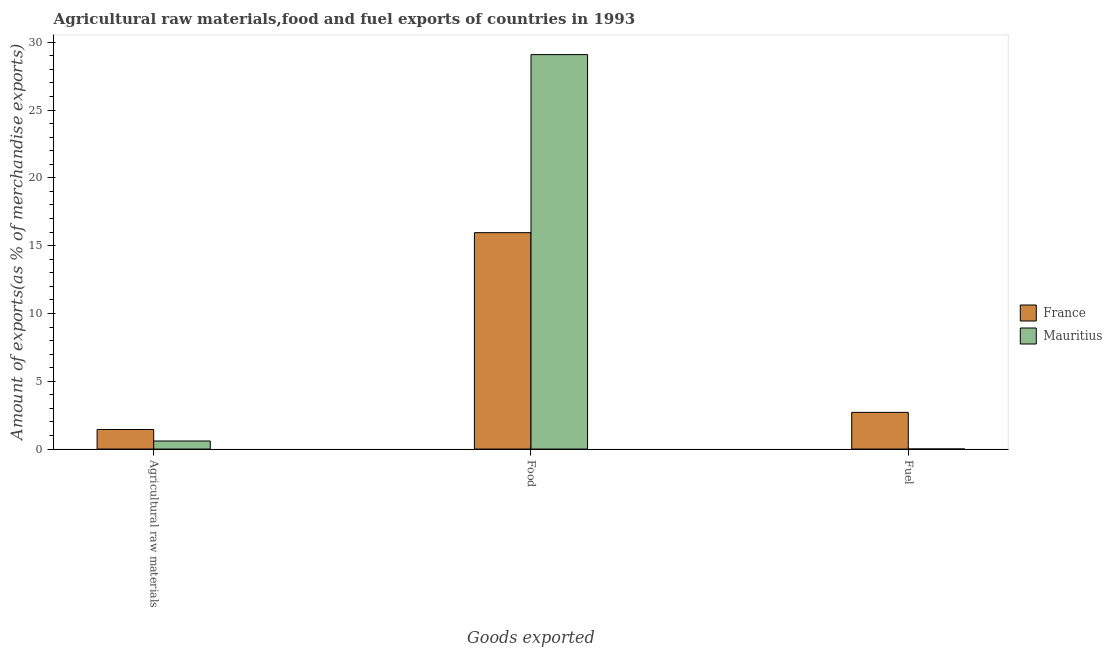How many different coloured bars are there?
Make the answer very short. 2. How many groups of bars are there?
Give a very brief answer. 3. Are the number of bars on each tick of the X-axis equal?
Make the answer very short. Yes. How many bars are there on the 3rd tick from the left?
Keep it short and to the point. 2. How many bars are there on the 3rd tick from the right?
Give a very brief answer. 2. What is the label of the 1st group of bars from the left?
Provide a short and direct response. Agricultural raw materials. What is the percentage of fuel exports in Mauritius?
Offer a very short reply. 0. Across all countries, what is the maximum percentage of food exports?
Offer a very short reply. 29.09. Across all countries, what is the minimum percentage of raw materials exports?
Provide a succinct answer. 0.6. In which country was the percentage of food exports maximum?
Offer a very short reply. Mauritius. What is the total percentage of food exports in the graph?
Provide a short and direct response. 45.04. What is the difference between the percentage of food exports in Mauritius and that in France?
Your response must be concise. 13.13. What is the difference between the percentage of raw materials exports in France and the percentage of food exports in Mauritius?
Your answer should be compact. -27.64. What is the average percentage of food exports per country?
Your answer should be very brief. 22.52. What is the difference between the percentage of raw materials exports and percentage of food exports in Mauritius?
Your answer should be compact. -28.49. In how many countries, is the percentage of food exports greater than 10 %?
Ensure brevity in your answer.  2. What is the ratio of the percentage of fuel exports in Mauritius to that in France?
Ensure brevity in your answer.  0. Is the percentage of fuel exports in Mauritius less than that in France?
Your answer should be very brief. Yes. Is the difference between the percentage of fuel exports in France and Mauritius greater than the difference between the percentage of raw materials exports in France and Mauritius?
Provide a succinct answer. Yes. What is the difference between the highest and the second highest percentage of food exports?
Your answer should be compact. 13.13. What is the difference between the highest and the lowest percentage of food exports?
Keep it short and to the point. 13.13. In how many countries, is the percentage of fuel exports greater than the average percentage of fuel exports taken over all countries?
Ensure brevity in your answer.  1. What does the 2nd bar from the left in Food represents?
Your answer should be very brief. Mauritius. How many bars are there?
Provide a succinct answer. 6. How many countries are there in the graph?
Ensure brevity in your answer.  2. Does the graph contain any zero values?
Your response must be concise. No. Does the graph contain grids?
Your answer should be compact. No. How many legend labels are there?
Offer a terse response. 2. How are the legend labels stacked?
Make the answer very short. Vertical. What is the title of the graph?
Make the answer very short. Agricultural raw materials,food and fuel exports of countries in 1993. What is the label or title of the X-axis?
Ensure brevity in your answer.  Goods exported. What is the label or title of the Y-axis?
Keep it short and to the point. Amount of exports(as % of merchandise exports). What is the Amount of exports(as % of merchandise exports) of France in Agricultural raw materials?
Ensure brevity in your answer.  1.44. What is the Amount of exports(as % of merchandise exports) in Mauritius in Agricultural raw materials?
Ensure brevity in your answer.  0.6. What is the Amount of exports(as % of merchandise exports) in France in Food?
Offer a very short reply. 15.96. What is the Amount of exports(as % of merchandise exports) in Mauritius in Food?
Provide a succinct answer. 29.09. What is the Amount of exports(as % of merchandise exports) in France in Fuel?
Give a very brief answer. 2.71. What is the Amount of exports(as % of merchandise exports) in Mauritius in Fuel?
Provide a short and direct response. 0. Across all Goods exported, what is the maximum Amount of exports(as % of merchandise exports) of France?
Make the answer very short. 15.96. Across all Goods exported, what is the maximum Amount of exports(as % of merchandise exports) of Mauritius?
Offer a very short reply. 29.09. Across all Goods exported, what is the minimum Amount of exports(as % of merchandise exports) in France?
Provide a short and direct response. 1.44. Across all Goods exported, what is the minimum Amount of exports(as % of merchandise exports) of Mauritius?
Make the answer very short. 0. What is the total Amount of exports(as % of merchandise exports) in France in the graph?
Offer a terse response. 20.11. What is the total Amount of exports(as % of merchandise exports) in Mauritius in the graph?
Your answer should be compact. 29.69. What is the difference between the Amount of exports(as % of merchandise exports) in France in Agricultural raw materials and that in Food?
Your answer should be very brief. -14.51. What is the difference between the Amount of exports(as % of merchandise exports) in Mauritius in Agricultural raw materials and that in Food?
Keep it short and to the point. -28.49. What is the difference between the Amount of exports(as % of merchandise exports) of France in Agricultural raw materials and that in Fuel?
Offer a very short reply. -1.26. What is the difference between the Amount of exports(as % of merchandise exports) of Mauritius in Agricultural raw materials and that in Fuel?
Offer a terse response. 0.59. What is the difference between the Amount of exports(as % of merchandise exports) of France in Food and that in Fuel?
Provide a short and direct response. 13.25. What is the difference between the Amount of exports(as % of merchandise exports) of Mauritius in Food and that in Fuel?
Ensure brevity in your answer.  29.08. What is the difference between the Amount of exports(as % of merchandise exports) of France in Agricultural raw materials and the Amount of exports(as % of merchandise exports) of Mauritius in Food?
Keep it short and to the point. -27.64. What is the difference between the Amount of exports(as % of merchandise exports) of France in Agricultural raw materials and the Amount of exports(as % of merchandise exports) of Mauritius in Fuel?
Offer a very short reply. 1.44. What is the difference between the Amount of exports(as % of merchandise exports) of France in Food and the Amount of exports(as % of merchandise exports) of Mauritius in Fuel?
Keep it short and to the point. 15.95. What is the average Amount of exports(as % of merchandise exports) of France per Goods exported?
Give a very brief answer. 6.7. What is the average Amount of exports(as % of merchandise exports) in Mauritius per Goods exported?
Your answer should be very brief. 9.9. What is the difference between the Amount of exports(as % of merchandise exports) of France and Amount of exports(as % of merchandise exports) of Mauritius in Agricultural raw materials?
Your answer should be very brief. 0.85. What is the difference between the Amount of exports(as % of merchandise exports) of France and Amount of exports(as % of merchandise exports) of Mauritius in Food?
Offer a very short reply. -13.13. What is the difference between the Amount of exports(as % of merchandise exports) of France and Amount of exports(as % of merchandise exports) of Mauritius in Fuel?
Make the answer very short. 2.7. What is the ratio of the Amount of exports(as % of merchandise exports) of France in Agricultural raw materials to that in Food?
Make the answer very short. 0.09. What is the ratio of the Amount of exports(as % of merchandise exports) in Mauritius in Agricultural raw materials to that in Food?
Your answer should be very brief. 0.02. What is the ratio of the Amount of exports(as % of merchandise exports) of France in Agricultural raw materials to that in Fuel?
Your response must be concise. 0.53. What is the ratio of the Amount of exports(as % of merchandise exports) in Mauritius in Agricultural raw materials to that in Fuel?
Provide a succinct answer. 165.74. What is the ratio of the Amount of exports(as % of merchandise exports) in France in Food to that in Fuel?
Offer a very short reply. 5.89. What is the ratio of the Amount of exports(as % of merchandise exports) of Mauritius in Food to that in Fuel?
Your response must be concise. 8089.14. What is the difference between the highest and the second highest Amount of exports(as % of merchandise exports) of France?
Make the answer very short. 13.25. What is the difference between the highest and the second highest Amount of exports(as % of merchandise exports) in Mauritius?
Give a very brief answer. 28.49. What is the difference between the highest and the lowest Amount of exports(as % of merchandise exports) in France?
Provide a succinct answer. 14.51. What is the difference between the highest and the lowest Amount of exports(as % of merchandise exports) in Mauritius?
Make the answer very short. 29.08. 